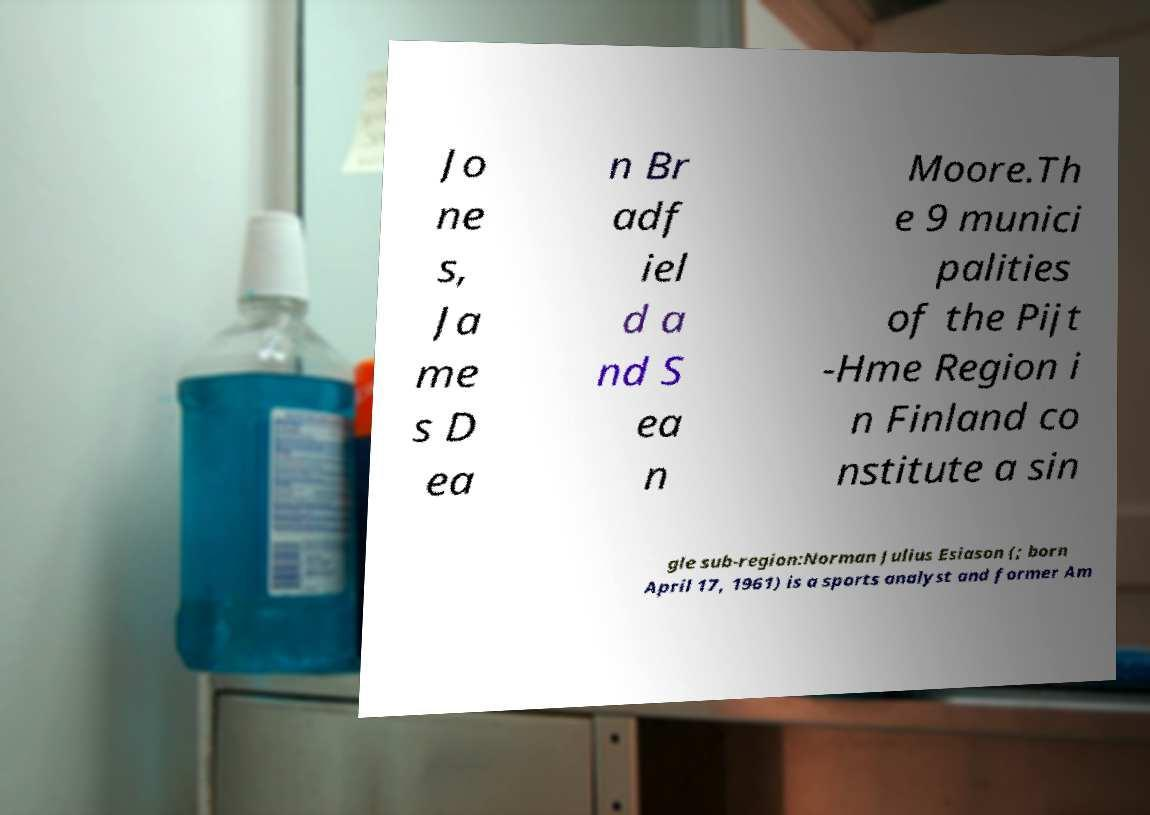Please read and relay the text visible in this image. What does it say? Jo ne s, Ja me s D ea n Br adf iel d a nd S ea n Moore.Th e 9 munici palities of the Pijt -Hme Region i n Finland co nstitute a sin gle sub-region:Norman Julius Esiason (; born April 17, 1961) is a sports analyst and former Am 